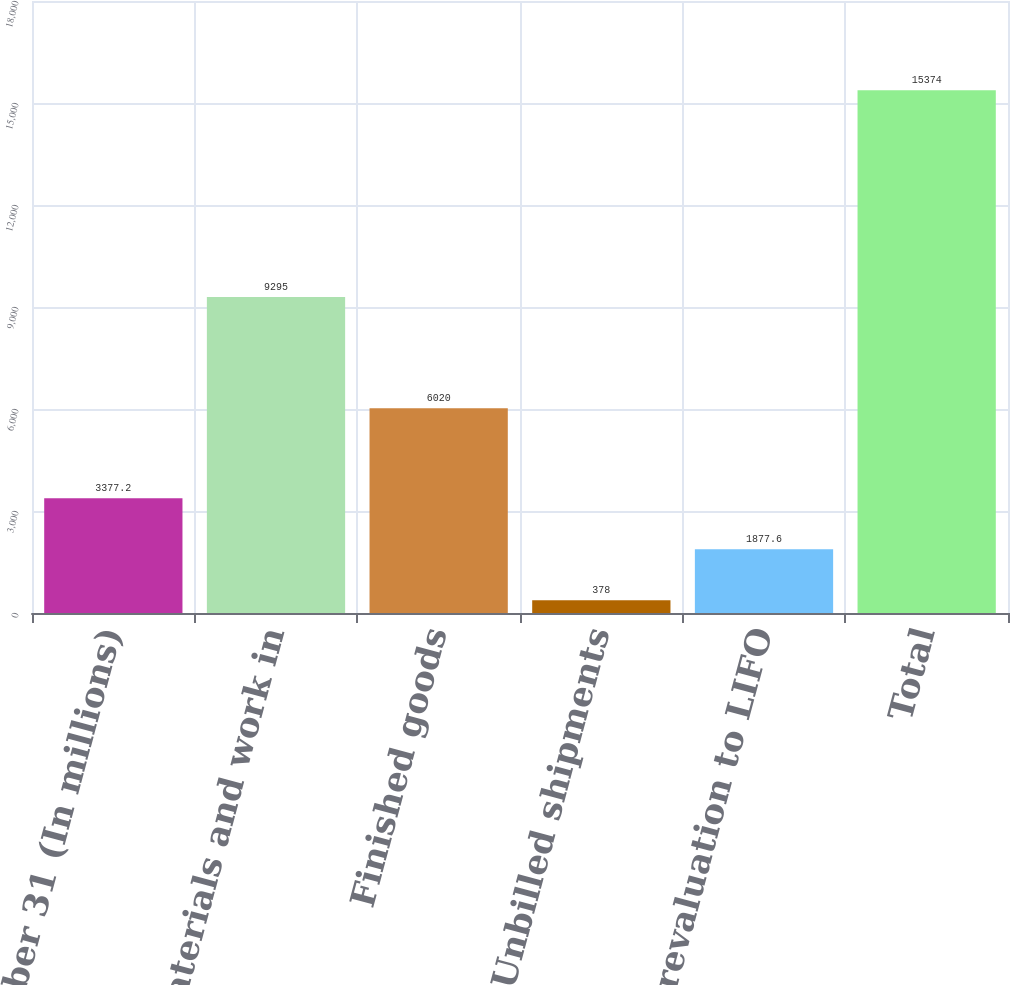Convert chart. <chart><loc_0><loc_0><loc_500><loc_500><bar_chart><fcel>December 31 (In millions)<fcel>Raw materials and work in<fcel>Finished goods<fcel>Unbilled shipments<fcel>Less revaluation to LIFO<fcel>Total<nl><fcel>3377.2<fcel>9295<fcel>6020<fcel>378<fcel>1877.6<fcel>15374<nl></chart> 